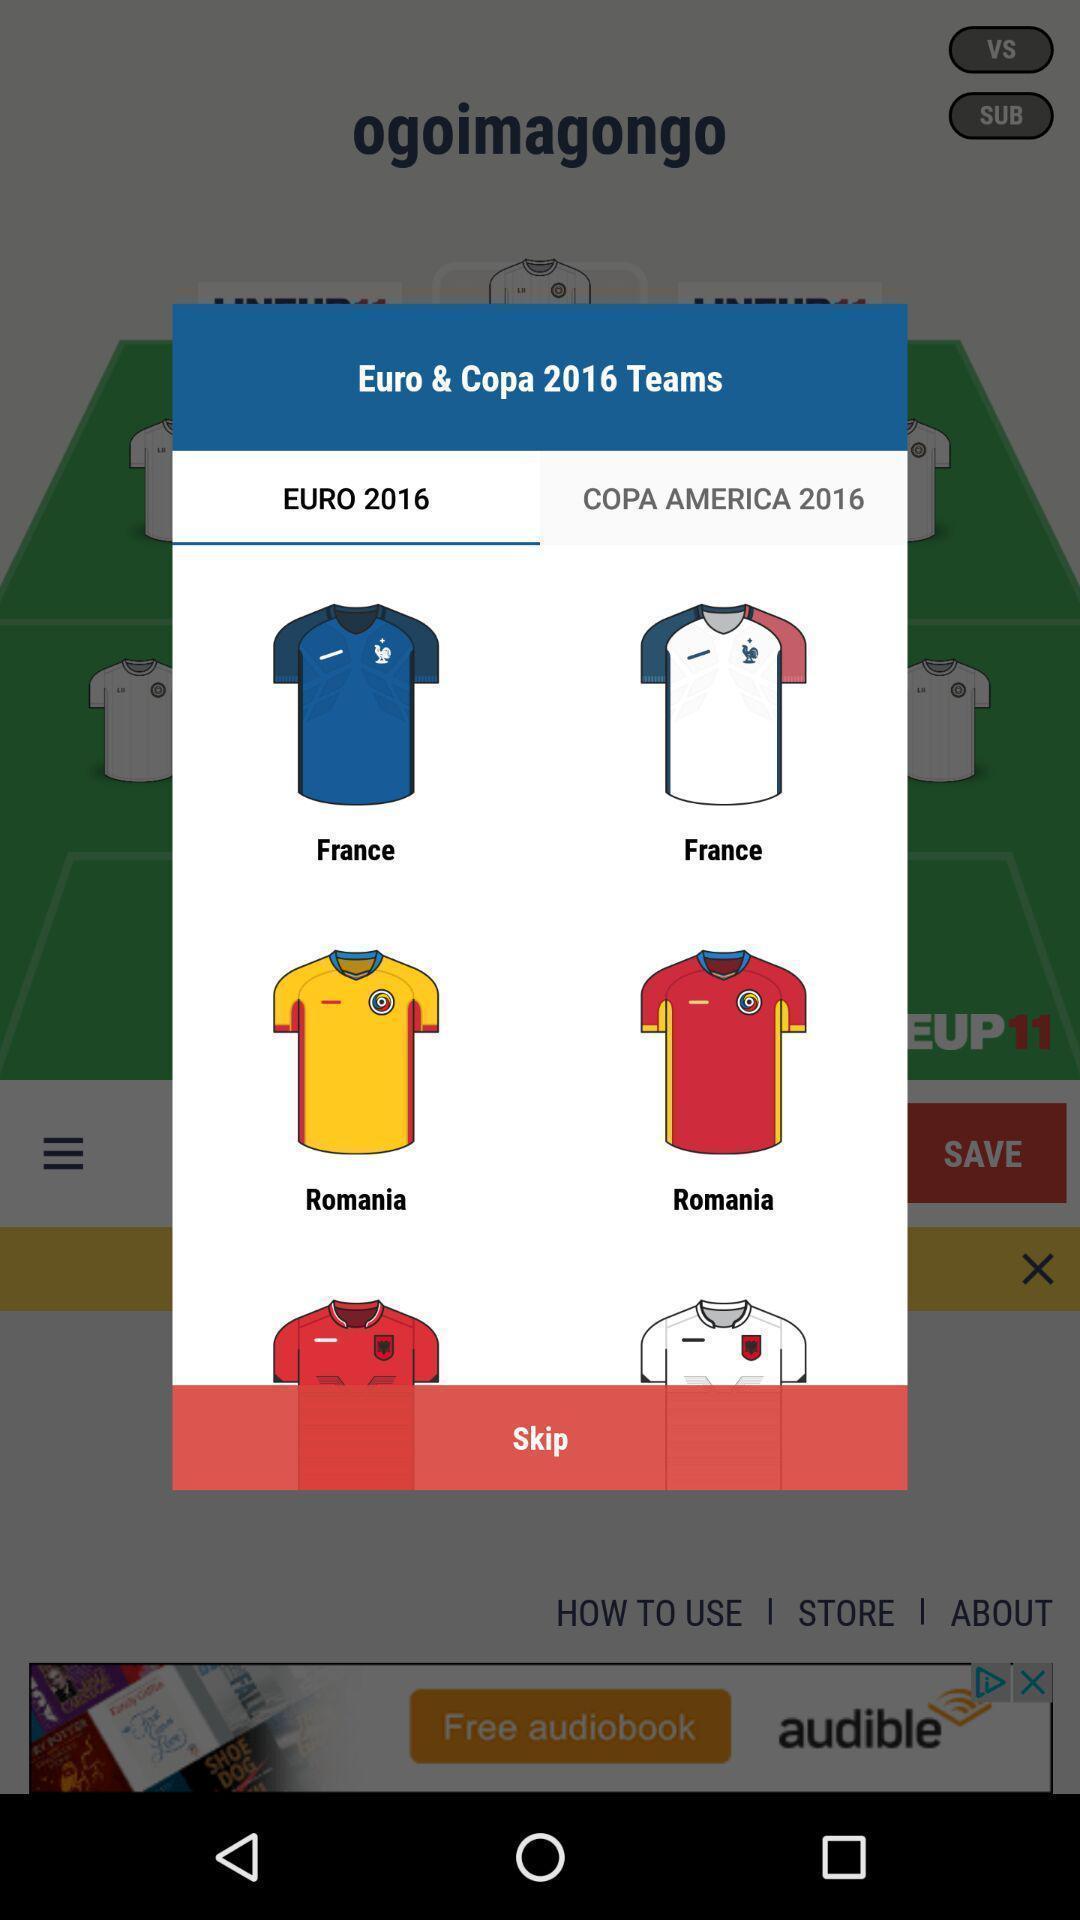Provide a description of this screenshot. Pop-up showing different team jerseys. 